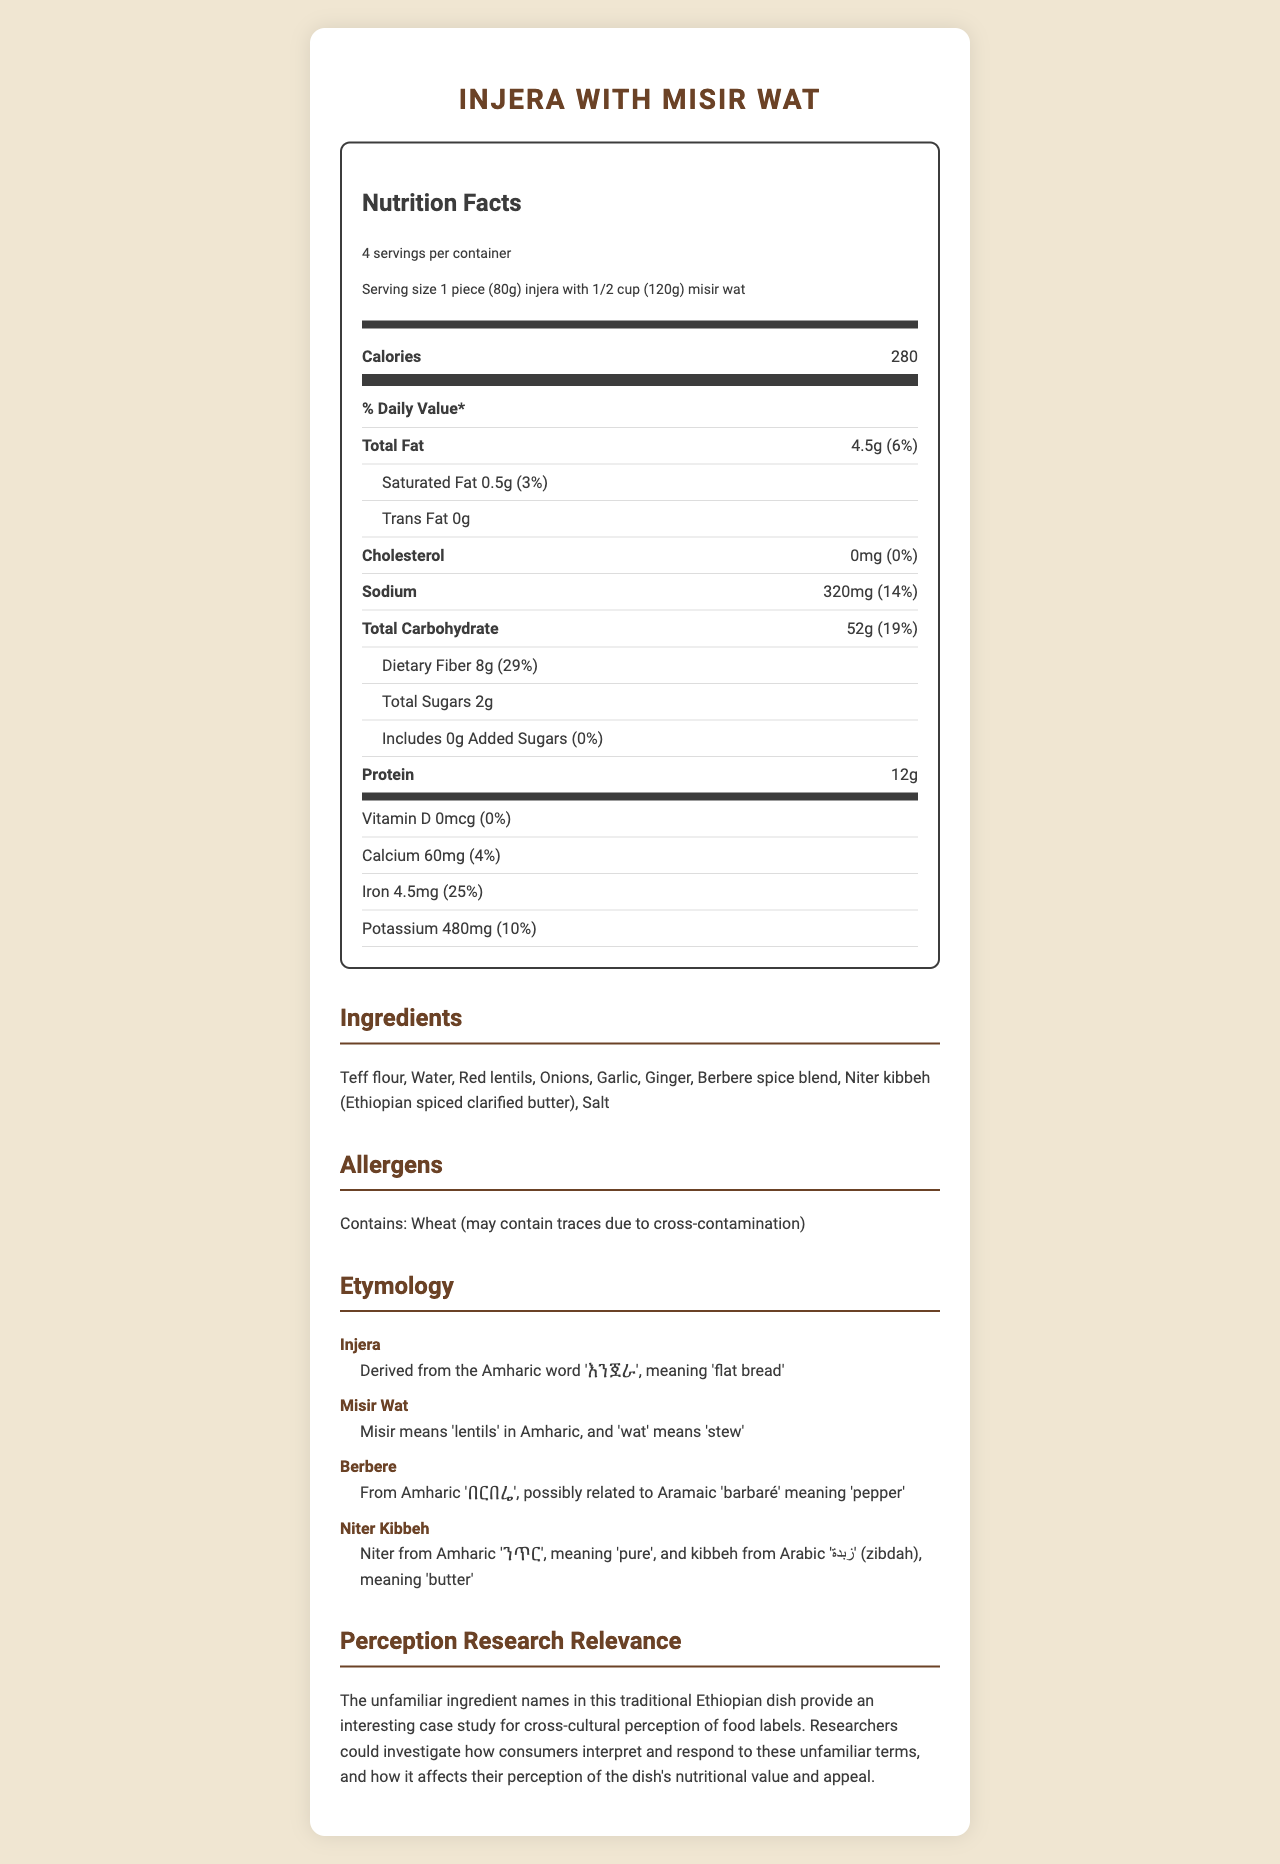what is the serving size? The serving size is indicated at the top of the nutrition label section.
Answer: 1 piece (80g) injera with 1/2 cup (120g) misir wat how many servings are in a container? The document states there are 4 servings per container in the nutrition facts section.
Answer: 4 how much protein does one serving contain? The amount of protein per serving is listed under the protein section of the nutrition label.
Answer: 12g what percentage of the daily value of dietary fiber is in one serving? The percentage daily value of dietary fiber is given next to the fiber amount in the document.
Answer: 29% does this dish contain any allergens? The allergens section lists wheat as a potential allergen due to cross-contamination.
Answer: Yes which ingredient might someone be unfamiliar with? A. Garlic B. Teff flour C. Water Teff flour is a less common ingredient compared to garlic and water.
Answer: B what is the amount of iron in one serving? A. 2mg B. 4.5mg C. 5mg The document lists 4.5mg of iron per serving.
Answer: B is there any added sugar in this dish? The document states that there are 0g of added sugars in the nutrition facts section.
Answer: No does the dish contain cholesterol? The document indicates that there is 0mg of cholesterol per serving.
Answer: No what does "injera" mean in Amharic? According to the etymology notes, "injera" is derived from the Amharic word meaning "flat bread".
Answer: Flat bread describe the main idea of this document. The main sections of the document include nutrition facts, ingredients, allergens, etymology notes, and relevance to perception research.
Answer: The document is a detailed nutrition facts label for "Injera with Misir Wat", listing nutritional information, ingredients, allergens, etymological notes, and the relevance of this dish for perception research related to food labels. what is the sodium content per serving and its daily value percentage? The nutrition facts section shows that each serving contains 320mg of sodium, which is 14% of the daily value.
Answer: 320mg, 14% what does "berbere" mean in the context of this dish? The etymology notes explain that "berbere" is possibly related to the Aramaic word 'barbaré' meaning 'pepper'.
Answer: Pepper how might unfamiliar ingredient names affect consumer perception? The document suggests this is an area for research, indicating how cross-cultural perceptions can alter consumers' views of nutritional value and appeal, but does not provide a definitive answer.
Answer: Incomplete information 